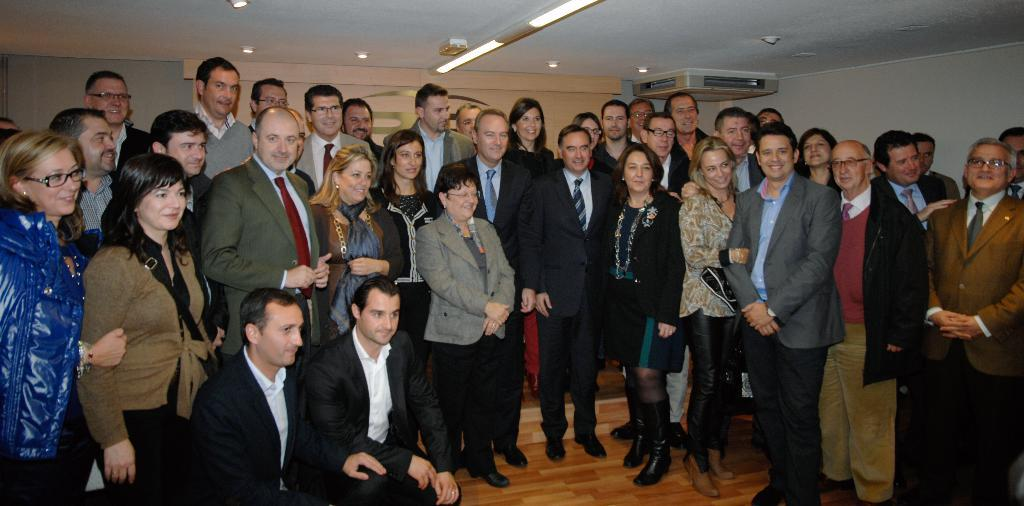What is happening with the group of people in the image? The people in the image are standing and smiling. Can you describe the condition of the two men on the floor? The two men on the floor are also visible in the image. What can be seen in the background of the image? In the background of the image, there are lights, walls, and some objects. What type of root can be seen growing on the wall in the image? There is no root visible on the wall in the image. 